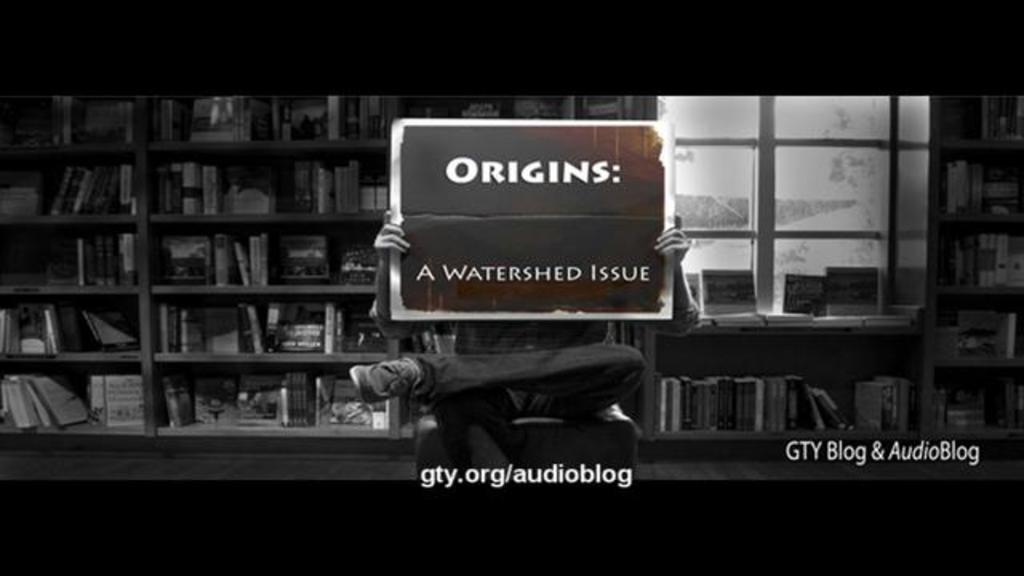Describe this image in one or two sentences. In the middle of the image there is a person sitting in the chair and holding the poster in their hands and on the poster there is something written on it. Behind them there is a cupboard with many books in it. And also there is a window at the right side of the image. Below the person there is a website address. And at the right bottom of the image there is a name. 